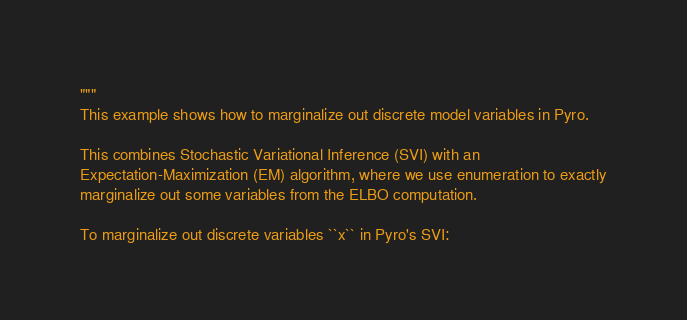Convert code to text. <code><loc_0><loc_0><loc_500><loc_500><_Python_>"""
This example shows how to marginalize out discrete model variables in Pyro.

This combines Stochastic Variational Inference (SVI) with an
Expectation-Maximization (EM) algorithm, where we use enumeration to exactly
marginalize out some variables from the ELBO computation.

To marginalize out discrete variables ``x`` in Pyro's SVI:</code> 